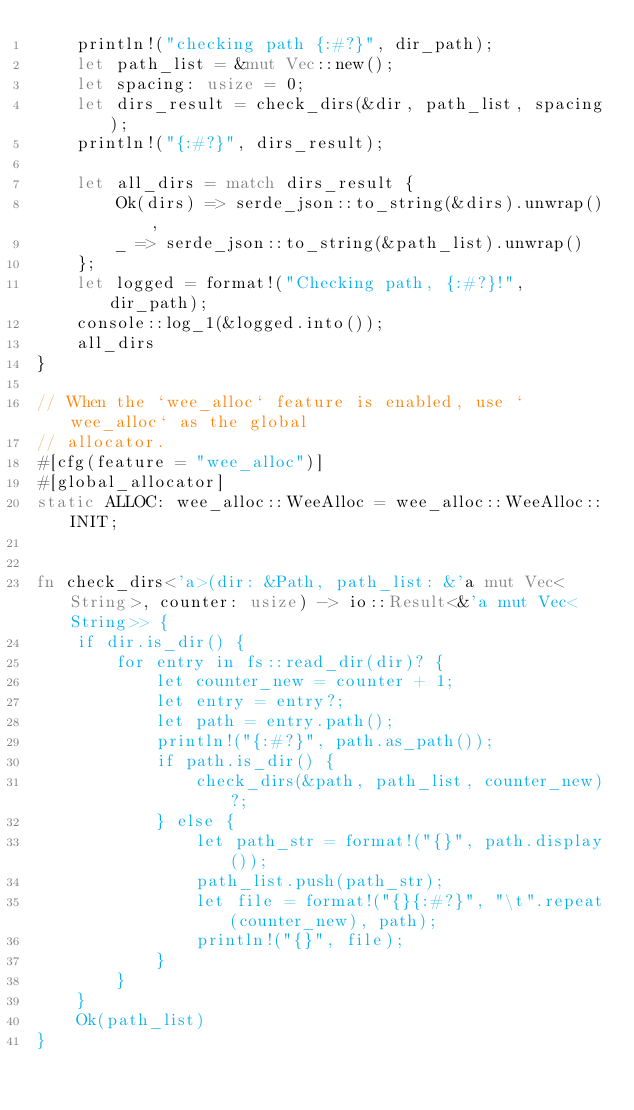Convert code to text. <code><loc_0><loc_0><loc_500><loc_500><_Rust_>    println!("checking path {:#?}", dir_path);
    let path_list = &mut Vec::new();
    let spacing: usize = 0;
    let dirs_result = check_dirs(&dir, path_list, spacing);
    println!("{:#?}", dirs_result);
    
    let all_dirs = match dirs_result {
        Ok(dirs) => serde_json::to_string(&dirs).unwrap(),
        _ => serde_json::to_string(&path_list).unwrap()
    };
    let logged = format!("Checking path, {:#?}!", dir_path);
    console::log_1(&logged.into());
    all_dirs
}

// When the `wee_alloc` feature is enabled, use `wee_alloc` as the global
// allocator.
#[cfg(feature = "wee_alloc")]
#[global_allocator]
static ALLOC: wee_alloc::WeeAlloc = wee_alloc::WeeAlloc::INIT;


fn check_dirs<'a>(dir: &Path, path_list: &'a mut Vec<String>, counter: usize) -> io::Result<&'a mut Vec<String>> {
    if dir.is_dir() {
        for entry in fs::read_dir(dir)? {
            let counter_new = counter + 1;
            let entry = entry?;
            let path = entry.path();
            println!("{:#?}", path.as_path());
            if path.is_dir() {
                check_dirs(&path, path_list, counter_new)?;
            } else {
                let path_str = format!("{}", path.display());
                path_list.push(path_str);
                let file = format!("{}{:#?}", "\t".repeat(counter_new), path);
                println!("{}", file);
            }
        }
    }
    Ok(path_list)
}
</code> 